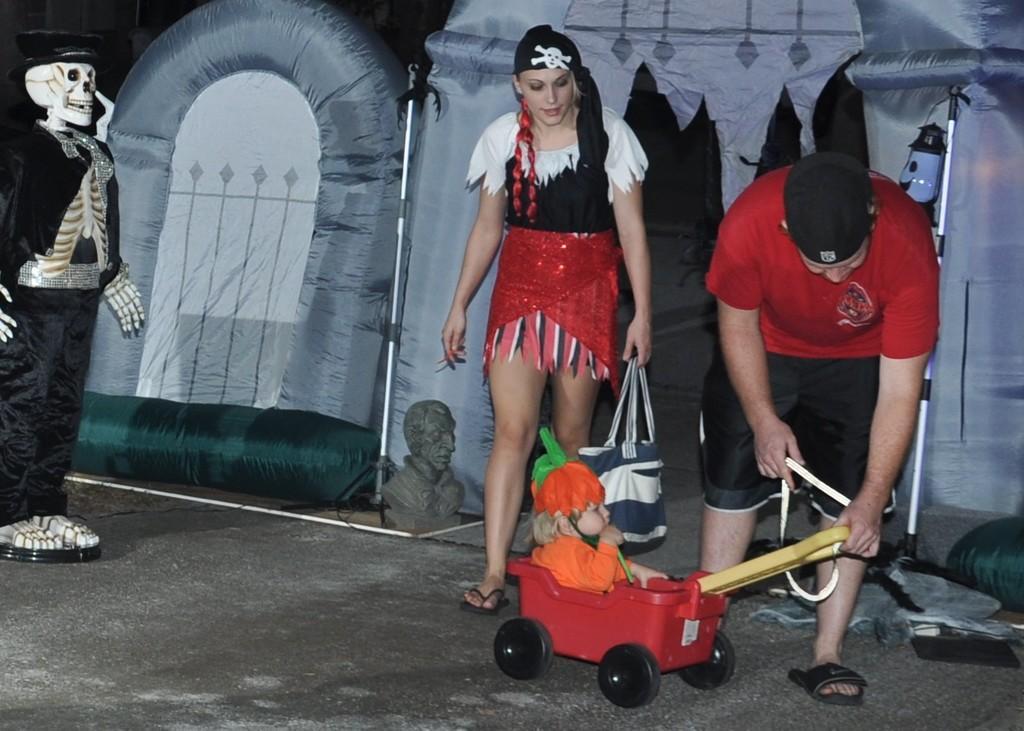How would you summarize this image in a sentence or two? On the left side of the image there is a skeleton with black dress. And on the right side of the image there is a man with red t-shirt, black short and cap on his head is standing and in his hand there is a stroller with a baby in it. Beside him there is a lady with white, black and red dress is stunning. Behind them there is a tent. 